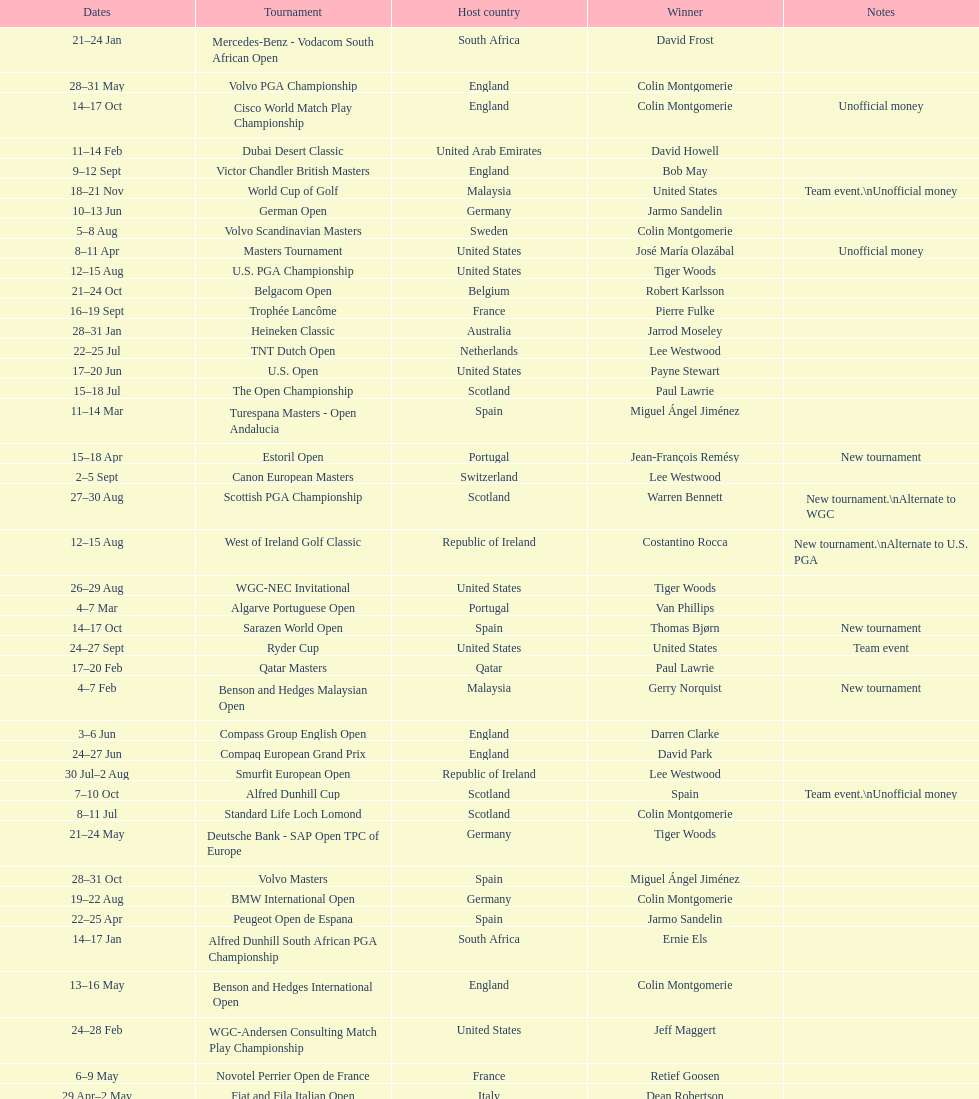How many consecutive times was south africa the host country? 2. 